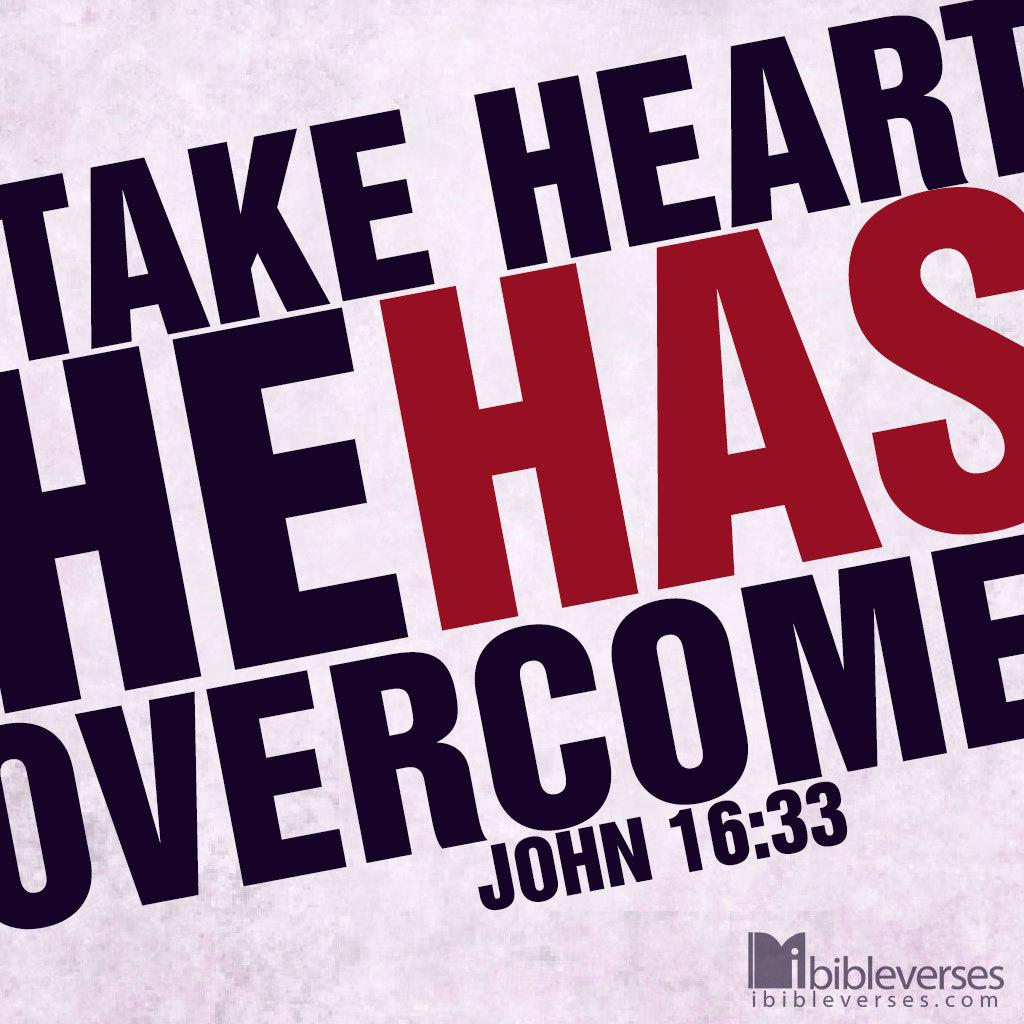<image>
Write a terse but informative summary of the picture. The bible verse, John 16:33, is rendered in a large contrasting color design. 